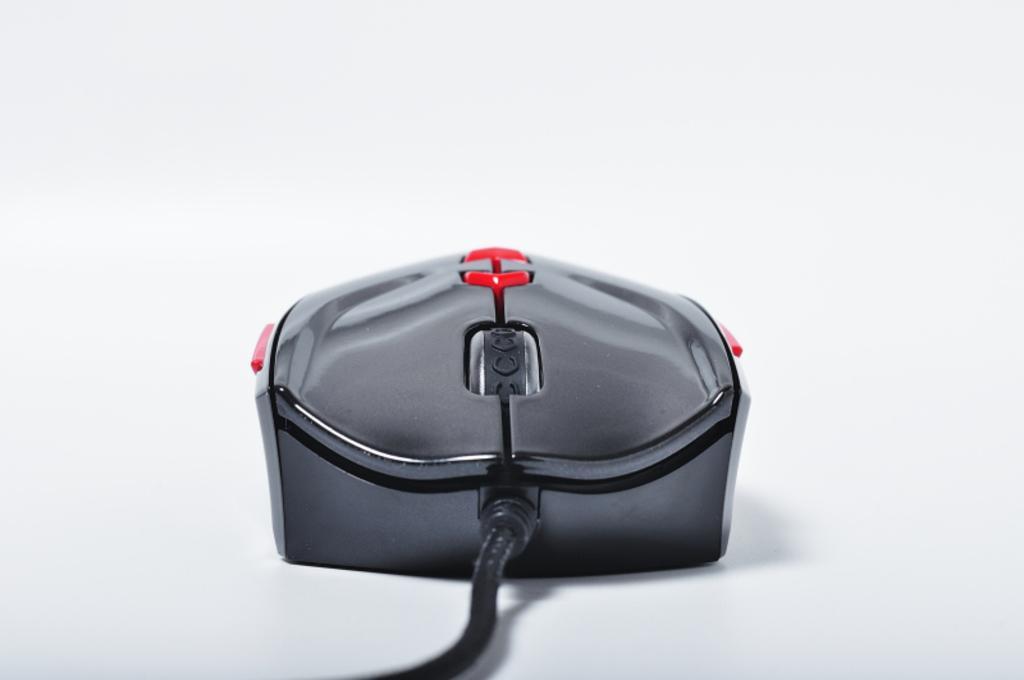Please provide a concise description of this image. In this image we can see a mouse with cable. Background it is in white color. 